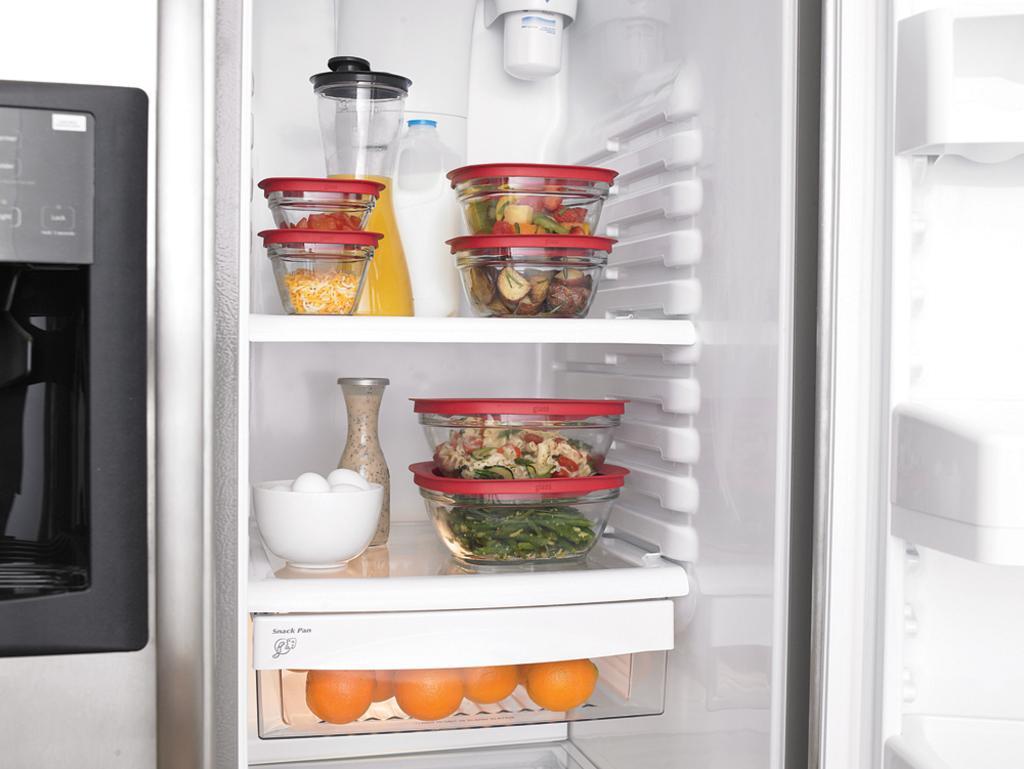Describe this image in one or two sentences. It is the fridge there are food items in it. 